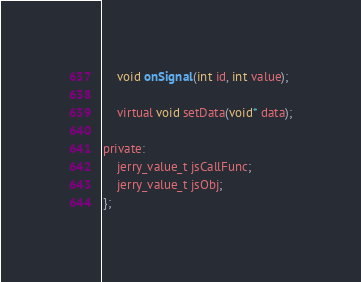Convert code to text. <code><loc_0><loc_0><loc_500><loc_500><_C_>    void onSignal(int id, int value);

    virtual void setData(void* data);

private:
    jerry_value_t jsCallFunc;
    jerry_value_t jsObj;
};
</code> 